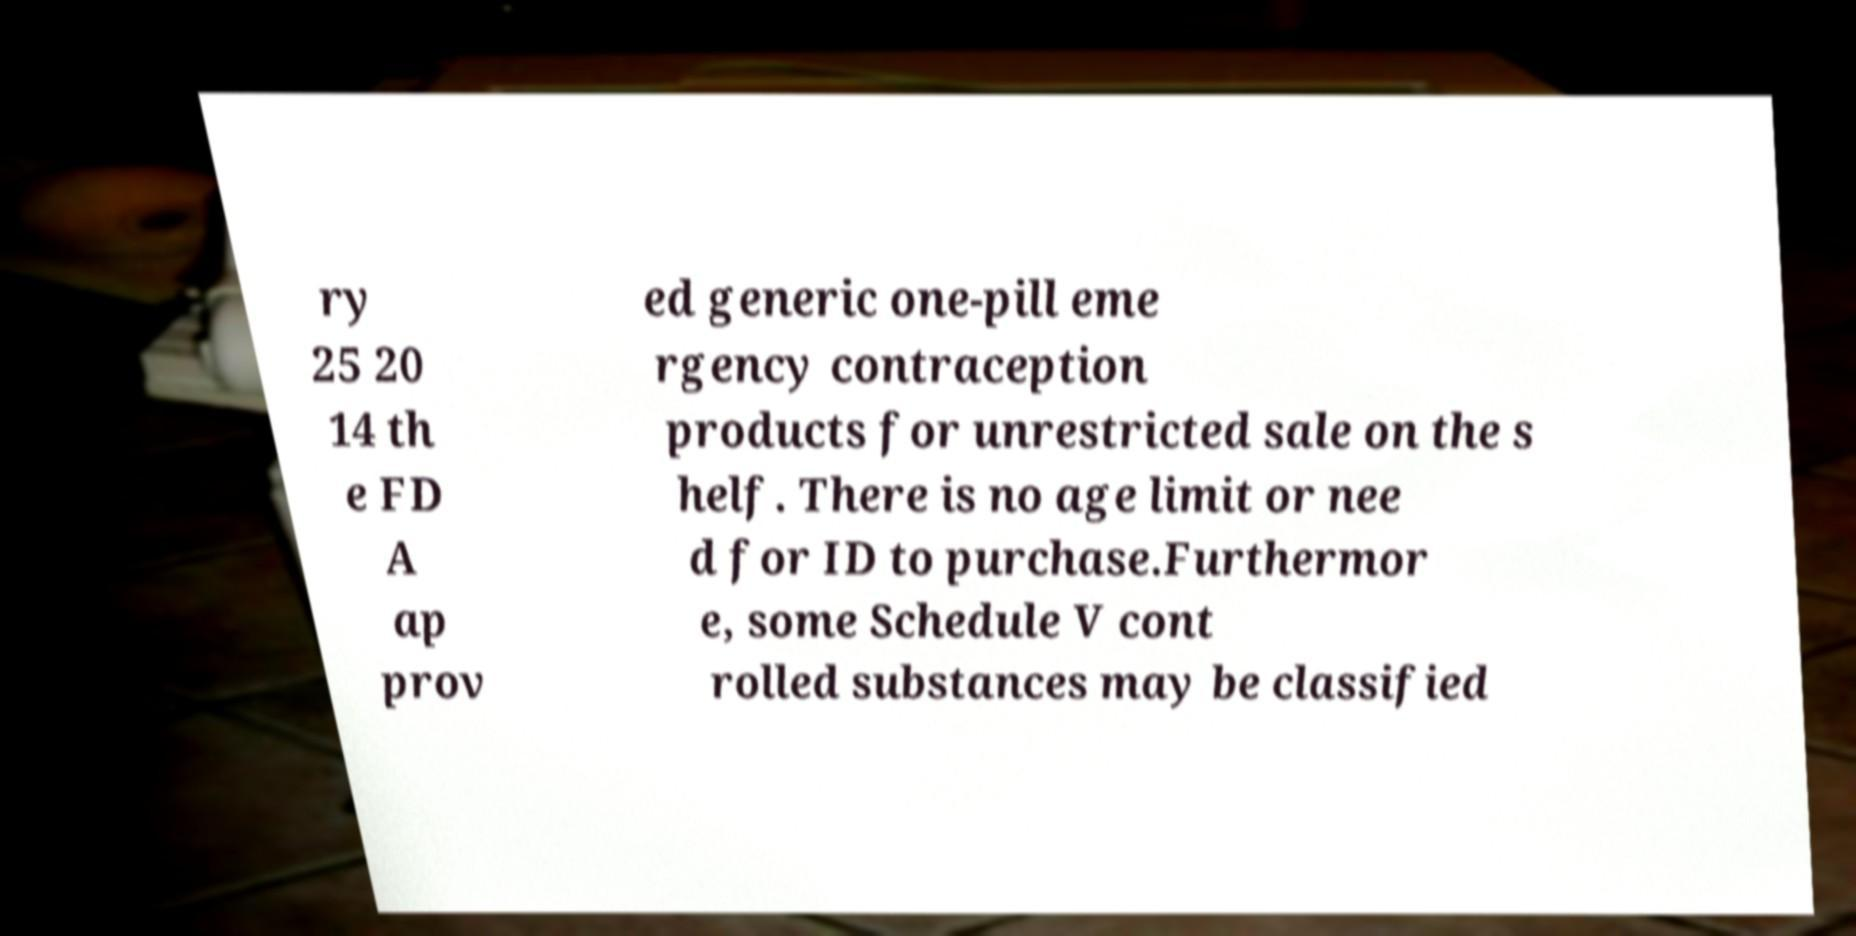I need the written content from this picture converted into text. Can you do that? ry 25 20 14 th e FD A ap prov ed generic one-pill eme rgency contraception products for unrestricted sale on the s helf. There is no age limit or nee d for ID to purchase.Furthermor e, some Schedule V cont rolled substances may be classified 